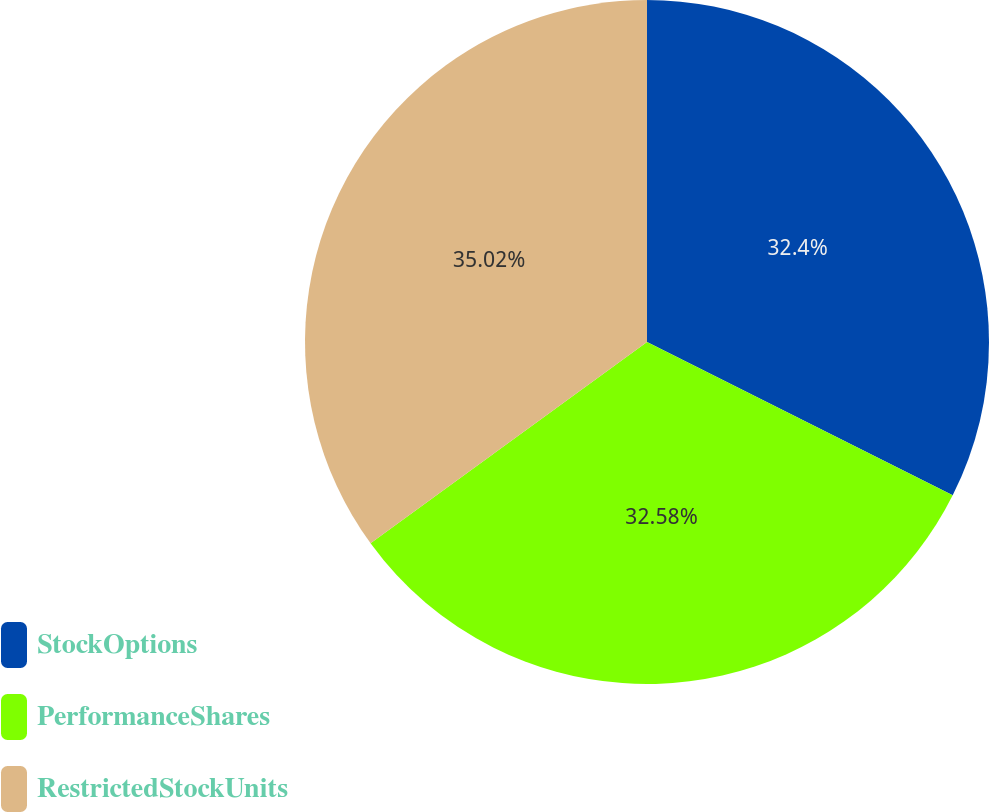<chart> <loc_0><loc_0><loc_500><loc_500><pie_chart><fcel>StockOptions<fcel>PerformanceShares<fcel>RestrictedStockUnits<nl><fcel>32.4%<fcel>32.58%<fcel>35.02%<nl></chart> 